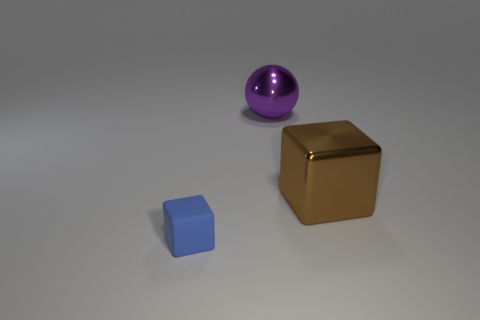Add 3 tiny purple metal blocks. How many objects exist? 6 Subtract all cubes. How many objects are left? 1 Add 2 big metal things. How many big metal things exist? 4 Subtract 0 brown cylinders. How many objects are left? 3 Subtract all small blue rubber cubes. Subtract all tiny purple metal cubes. How many objects are left? 2 Add 3 large purple metallic spheres. How many large purple metallic spheres are left? 4 